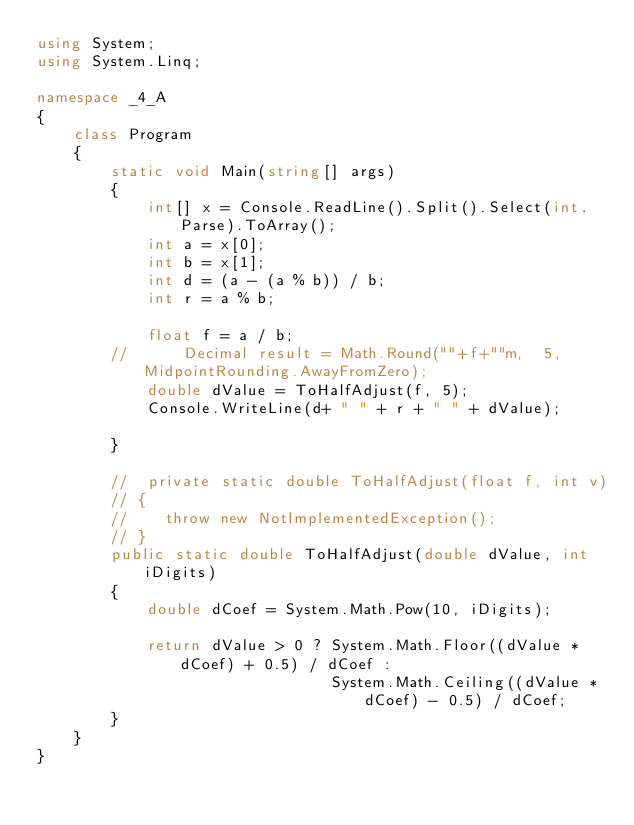Convert code to text. <code><loc_0><loc_0><loc_500><loc_500><_C#_>using System;
using System.Linq;

namespace _4_A
{
    class Program
    {
        static void Main(string[] args)
        {
            int[] x = Console.ReadLine().Split().Select(int.Parse).ToArray();
            int a = x[0];
            int b = x[1];
            int d = (a - (a % b)) / b;
            int r = a % b;
          
            float f = a / b;
        //      Decimal result = Math.Round(""+f+""m,  5, MidpointRounding.AwayFromZero);
            double dValue = ToHalfAdjust(f, 5);
            Console.WriteLine(d+ " " + r + " " + dValue);

        }

        //  private static double ToHalfAdjust(float f, int v)
        // {
        //    throw new NotImplementedException();
        // }
        public static double ToHalfAdjust(double dValue, int iDigits)
        {
            double dCoef = System.Math.Pow(10, iDigits);

            return dValue > 0 ? System.Math.Floor((dValue * dCoef) + 0.5) / dCoef :
                                System.Math.Ceiling((dValue * dCoef) - 0.5) / dCoef;
        }
    }
}</code> 